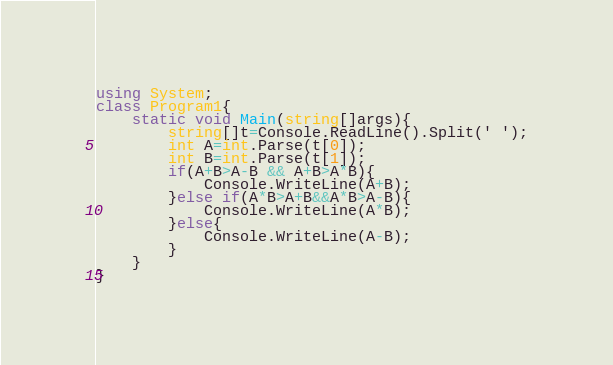Convert code to text. <code><loc_0><loc_0><loc_500><loc_500><_C#_>using System;
class Program1{
    static void Main(string[]args){
        string[]t=Console.ReadLine().Split(' ');
        int A=int.Parse(t[0]);
        int B=int.Parse(t[1]);
        if(A+B>A-B && A+B>A*B){
            Console.WriteLine(A+B);
        }else if(A*B>A+B&&A*B>A-B){
            Console.WriteLine(A*B);
        }else{
            Console.WriteLine(A-B);
        }
    }
}</code> 